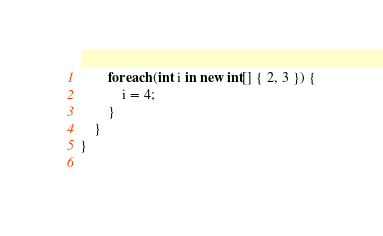<code> <loc_0><loc_0><loc_500><loc_500><_C#_>		foreach (int i in new int[] { 2, 3 }) {
		    i = 4;
		}
	}
}
	
</code> 